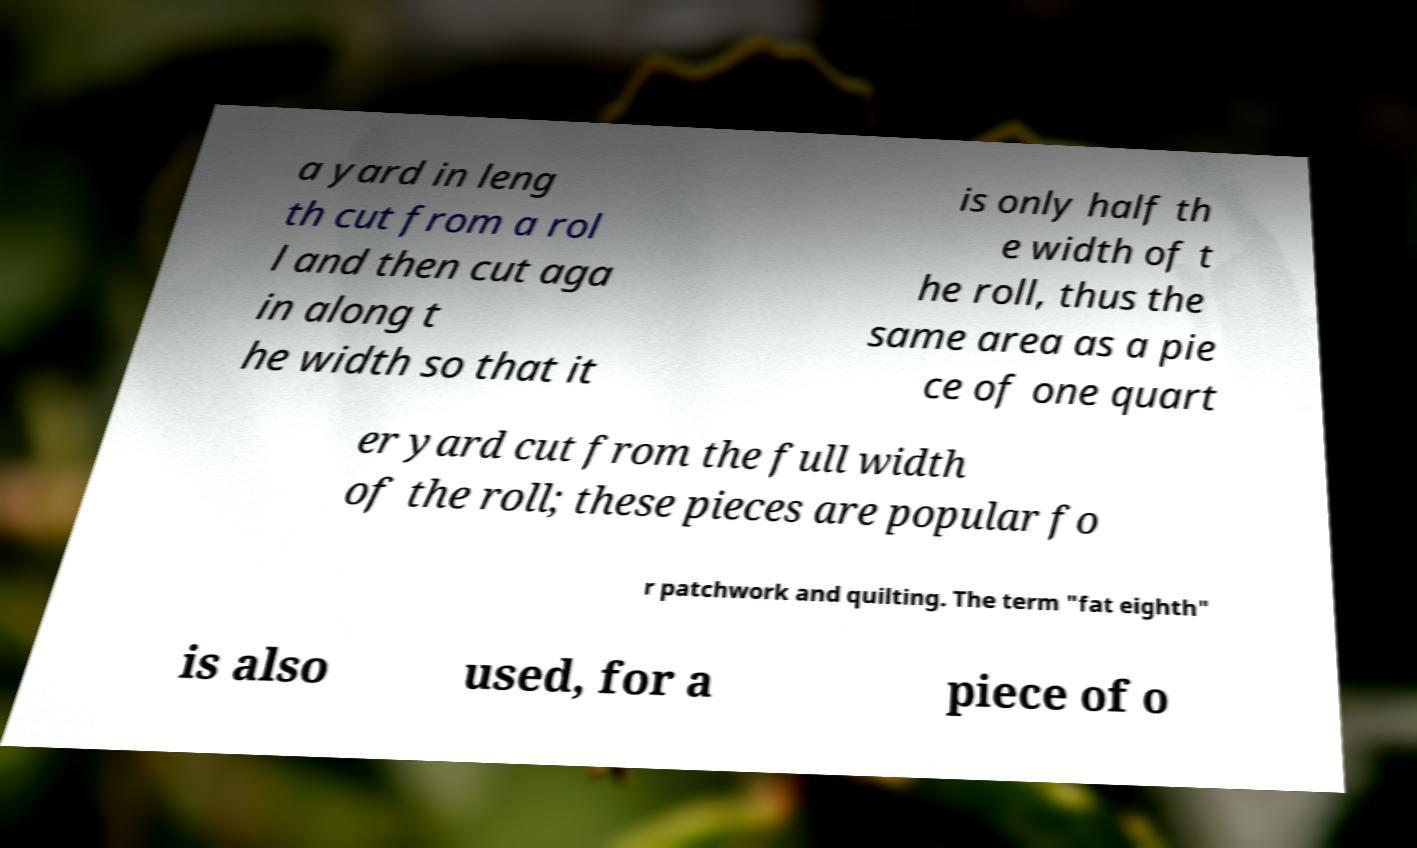What messages or text are displayed in this image? I need them in a readable, typed format. a yard in leng th cut from a rol l and then cut aga in along t he width so that it is only half th e width of t he roll, thus the same area as a pie ce of one quart er yard cut from the full width of the roll; these pieces are popular fo r patchwork and quilting. The term "fat eighth" is also used, for a piece of o 